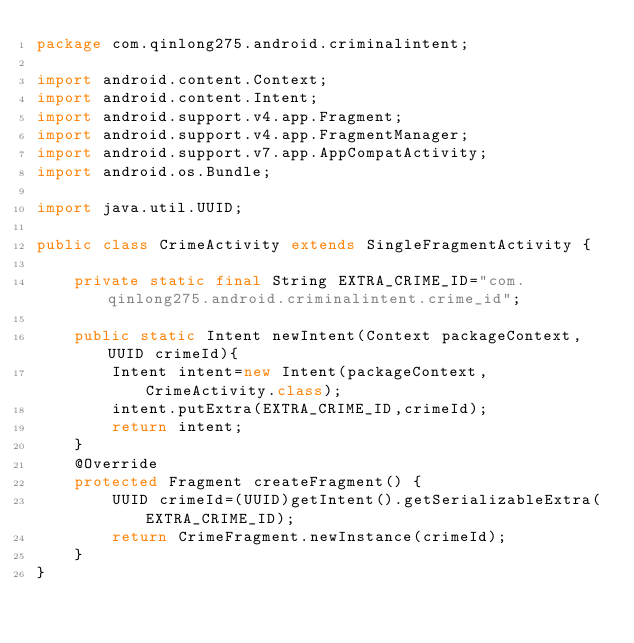Convert code to text. <code><loc_0><loc_0><loc_500><loc_500><_Java_>package com.qinlong275.android.criminalintent;

import android.content.Context;
import android.content.Intent;
import android.support.v4.app.Fragment;
import android.support.v4.app.FragmentManager;
import android.support.v7.app.AppCompatActivity;
import android.os.Bundle;

import java.util.UUID;

public class CrimeActivity extends SingleFragmentActivity {

    private static final String EXTRA_CRIME_ID="com.qinlong275.android.criminalintent.crime_id";

    public static Intent newIntent(Context packageContext, UUID crimeId){
        Intent intent=new Intent(packageContext,CrimeActivity.class);
        intent.putExtra(EXTRA_CRIME_ID,crimeId);
        return intent;
    }
    @Override
    protected Fragment createFragment() {
        UUID crimeId=(UUID)getIntent().getSerializableExtra(EXTRA_CRIME_ID);
        return CrimeFragment.newInstance(crimeId);
    }
}
</code> 